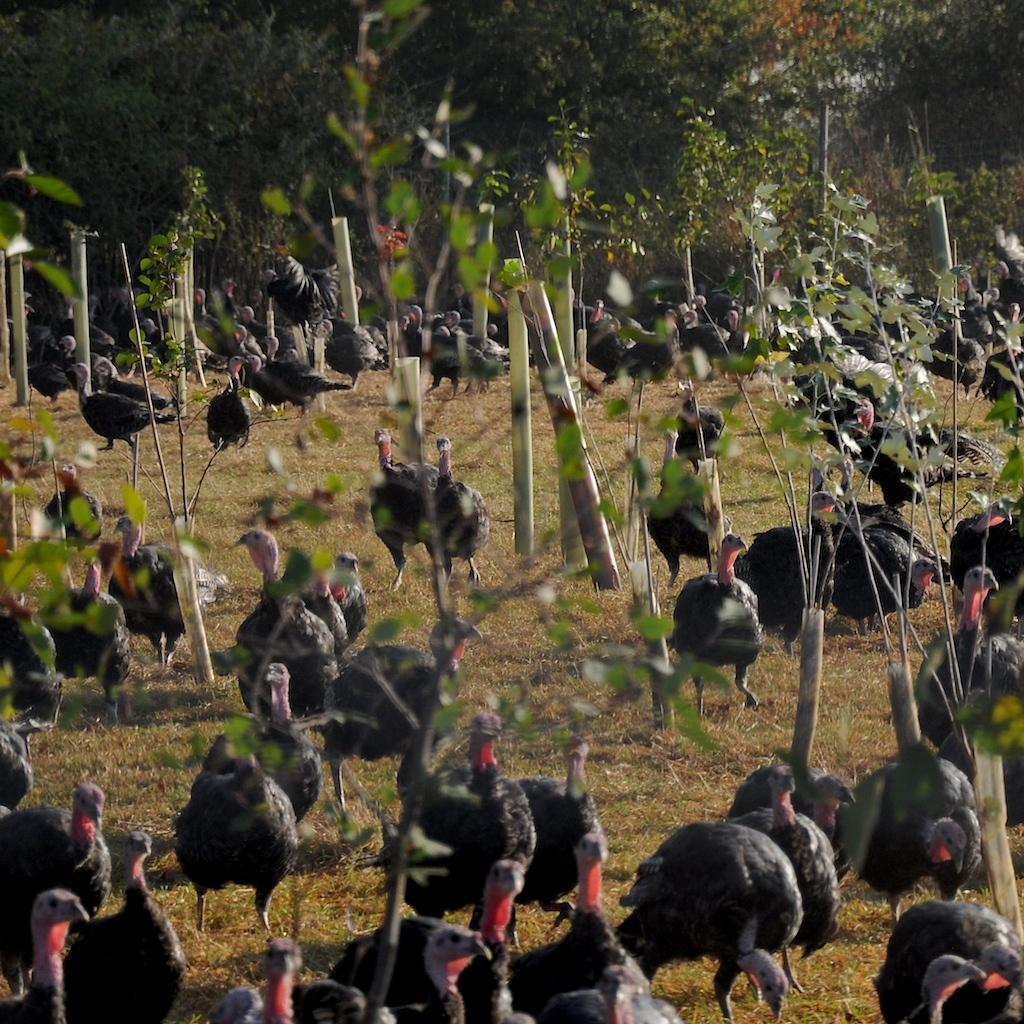What type of animals are on the ground in the image? There are emu birds on the ground in the image. What can be seen in the middle of the image? There are plants in the middle of the image. What is visible in the background of the image? There are trees visible in the background of the image. What type of dinner is being served at the company event in the image? There is no dinner or company event present in the image; it features emu birds on the ground, plants in the middle, and trees in the background. 